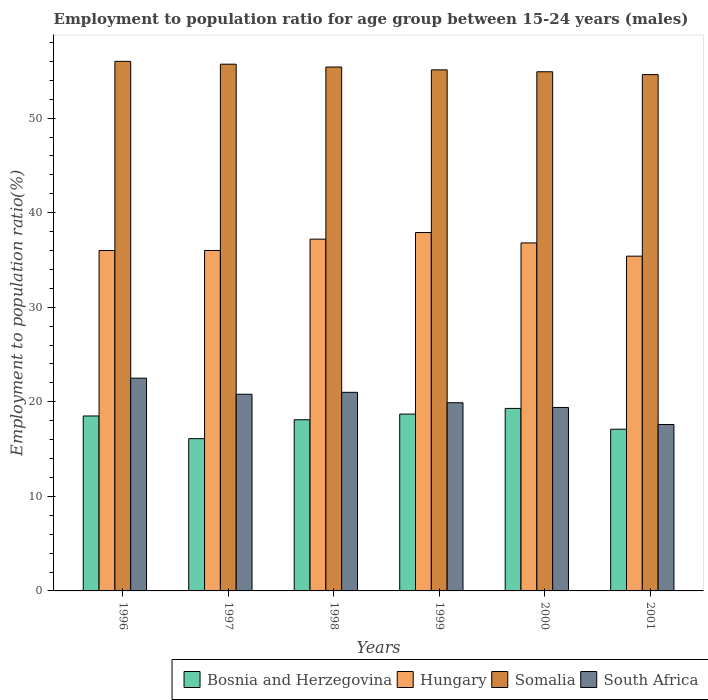How many different coloured bars are there?
Your response must be concise. 4. How many groups of bars are there?
Offer a terse response. 6. Are the number of bars per tick equal to the number of legend labels?
Make the answer very short. Yes. Are the number of bars on each tick of the X-axis equal?
Make the answer very short. Yes. What is the label of the 5th group of bars from the left?
Your response must be concise. 2000. What is the employment to population ratio in Somalia in 2000?
Give a very brief answer. 54.9. Across all years, what is the minimum employment to population ratio in Somalia?
Give a very brief answer. 54.6. In which year was the employment to population ratio in South Africa minimum?
Provide a succinct answer. 2001. What is the total employment to population ratio in South Africa in the graph?
Your answer should be very brief. 121.2. What is the difference between the employment to population ratio in South Africa in 1996 and that in 1998?
Keep it short and to the point. 1.5. What is the difference between the employment to population ratio in Hungary in 1998 and the employment to population ratio in Somalia in 1996?
Offer a terse response. -18.8. What is the average employment to population ratio in Bosnia and Herzegovina per year?
Your response must be concise. 17.97. In the year 1996, what is the difference between the employment to population ratio in Hungary and employment to population ratio in Somalia?
Keep it short and to the point. -20. What is the ratio of the employment to population ratio in Somalia in 1998 to that in 2001?
Your answer should be very brief. 1.01. What is the difference between the highest and the second highest employment to population ratio in South Africa?
Your answer should be very brief. 1.5. What is the difference between the highest and the lowest employment to population ratio in Hungary?
Make the answer very short. 2.5. Is the sum of the employment to population ratio in Somalia in 1998 and 2000 greater than the maximum employment to population ratio in South Africa across all years?
Offer a terse response. Yes. Is it the case that in every year, the sum of the employment to population ratio in Somalia and employment to population ratio in Bosnia and Herzegovina is greater than the sum of employment to population ratio in Hungary and employment to population ratio in South Africa?
Your response must be concise. No. What does the 1st bar from the left in 2001 represents?
Offer a terse response. Bosnia and Herzegovina. What does the 2nd bar from the right in 2001 represents?
Your answer should be very brief. Somalia. Is it the case that in every year, the sum of the employment to population ratio in South Africa and employment to population ratio in Bosnia and Herzegovina is greater than the employment to population ratio in Hungary?
Your answer should be compact. No. What is the difference between two consecutive major ticks on the Y-axis?
Your answer should be very brief. 10. Does the graph contain any zero values?
Offer a terse response. No. Does the graph contain grids?
Provide a short and direct response. No. How many legend labels are there?
Provide a succinct answer. 4. What is the title of the graph?
Your answer should be very brief. Employment to population ratio for age group between 15-24 years (males). Does "Slovenia" appear as one of the legend labels in the graph?
Give a very brief answer. No. What is the label or title of the Y-axis?
Keep it short and to the point. Employment to population ratio(%). What is the Employment to population ratio(%) in Bosnia and Herzegovina in 1996?
Ensure brevity in your answer.  18.5. What is the Employment to population ratio(%) of Bosnia and Herzegovina in 1997?
Your response must be concise. 16.1. What is the Employment to population ratio(%) in Hungary in 1997?
Keep it short and to the point. 36. What is the Employment to population ratio(%) in Somalia in 1997?
Give a very brief answer. 55.7. What is the Employment to population ratio(%) of South Africa in 1997?
Ensure brevity in your answer.  20.8. What is the Employment to population ratio(%) in Bosnia and Herzegovina in 1998?
Keep it short and to the point. 18.1. What is the Employment to population ratio(%) in Hungary in 1998?
Your response must be concise. 37.2. What is the Employment to population ratio(%) in Somalia in 1998?
Your answer should be very brief. 55.4. What is the Employment to population ratio(%) of Bosnia and Herzegovina in 1999?
Offer a terse response. 18.7. What is the Employment to population ratio(%) in Hungary in 1999?
Keep it short and to the point. 37.9. What is the Employment to population ratio(%) of Somalia in 1999?
Your answer should be compact. 55.1. What is the Employment to population ratio(%) in South Africa in 1999?
Give a very brief answer. 19.9. What is the Employment to population ratio(%) in Bosnia and Herzegovina in 2000?
Ensure brevity in your answer.  19.3. What is the Employment to population ratio(%) in Hungary in 2000?
Provide a succinct answer. 36.8. What is the Employment to population ratio(%) in Somalia in 2000?
Provide a short and direct response. 54.9. What is the Employment to population ratio(%) in South Africa in 2000?
Offer a very short reply. 19.4. What is the Employment to population ratio(%) in Bosnia and Herzegovina in 2001?
Provide a succinct answer. 17.1. What is the Employment to population ratio(%) in Hungary in 2001?
Keep it short and to the point. 35.4. What is the Employment to population ratio(%) of Somalia in 2001?
Make the answer very short. 54.6. What is the Employment to population ratio(%) in South Africa in 2001?
Make the answer very short. 17.6. Across all years, what is the maximum Employment to population ratio(%) of Bosnia and Herzegovina?
Give a very brief answer. 19.3. Across all years, what is the maximum Employment to population ratio(%) in Hungary?
Offer a very short reply. 37.9. Across all years, what is the minimum Employment to population ratio(%) in Bosnia and Herzegovina?
Keep it short and to the point. 16.1. Across all years, what is the minimum Employment to population ratio(%) of Hungary?
Keep it short and to the point. 35.4. Across all years, what is the minimum Employment to population ratio(%) in Somalia?
Make the answer very short. 54.6. Across all years, what is the minimum Employment to population ratio(%) in South Africa?
Provide a succinct answer. 17.6. What is the total Employment to population ratio(%) in Bosnia and Herzegovina in the graph?
Your answer should be compact. 107.8. What is the total Employment to population ratio(%) in Hungary in the graph?
Make the answer very short. 219.3. What is the total Employment to population ratio(%) in Somalia in the graph?
Offer a very short reply. 331.7. What is the total Employment to population ratio(%) of South Africa in the graph?
Offer a terse response. 121.2. What is the difference between the Employment to population ratio(%) in Bosnia and Herzegovina in 1996 and that in 1997?
Your answer should be compact. 2.4. What is the difference between the Employment to population ratio(%) in Somalia in 1996 and that in 1997?
Keep it short and to the point. 0.3. What is the difference between the Employment to population ratio(%) in South Africa in 1996 and that in 1997?
Your answer should be very brief. 1.7. What is the difference between the Employment to population ratio(%) of Hungary in 1996 and that in 1998?
Provide a short and direct response. -1.2. What is the difference between the Employment to population ratio(%) of Somalia in 1996 and that in 1998?
Provide a succinct answer. 0.6. What is the difference between the Employment to population ratio(%) of South Africa in 1996 and that in 1998?
Keep it short and to the point. 1.5. What is the difference between the Employment to population ratio(%) of Bosnia and Herzegovina in 1996 and that in 1999?
Give a very brief answer. -0.2. What is the difference between the Employment to population ratio(%) in Somalia in 1996 and that in 1999?
Provide a succinct answer. 0.9. What is the difference between the Employment to population ratio(%) of Hungary in 1996 and that in 2000?
Offer a very short reply. -0.8. What is the difference between the Employment to population ratio(%) of Bosnia and Herzegovina in 1996 and that in 2001?
Ensure brevity in your answer.  1.4. What is the difference between the Employment to population ratio(%) of Hungary in 1996 and that in 2001?
Your answer should be very brief. 0.6. What is the difference between the Employment to population ratio(%) of Somalia in 1996 and that in 2001?
Offer a very short reply. 1.4. What is the difference between the Employment to population ratio(%) of Bosnia and Herzegovina in 1997 and that in 1999?
Give a very brief answer. -2.6. What is the difference between the Employment to population ratio(%) in Somalia in 1997 and that in 1999?
Provide a short and direct response. 0.6. What is the difference between the Employment to population ratio(%) of South Africa in 1997 and that in 1999?
Your answer should be very brief. 0.9. What is the difference between the Employment to population ratio(%) in Hungary in 1997 and that in 2000?
Your answer should be very brief. -0.8. What is the difference between the Employment to population ratio(%) in Hungary in 1997 and that in 2001?
Keep it short and to the point. 0.6. What is the difference between the Employment to population ratio(%) in South Africa in 1997 and that in 2001?
Provide a short and direct response. 3.2. What is the difference between the Employment to population ratio(%) in Somalia in 1998 and that in 1999?
Offer a terse response. 0.3. What is the difference between the Employment to population ratio(%) in South Africa in 1998 and that in 1999?
Your answer should be very brief. 1.1. What is the difference between the Employment to population ratio(%) in Hungary in 1998 and that in 2000?
Provide a short and direct response. 0.4. What is the difference between the Employment to population ratio(%) in Somalia in 1998 and that in 2000?
Ensure brevity in your answer.  0.5. What is the difference between the Employment to population ratio(%) of Bosnia and Herzegovina in 1998 and that in 2001?
Ensure brevity in your answer.  1. What is the difference between the Employment to population ratio(%) in Bosnia and Herzegovina in 1999 and that in 2000?
Offer a terse response. -0.6. What is the difference between the Employment to population ratio(%) in Somalia in 1999 and that in 2000?
Provide a short and direct response. 0.2. What is the difference between the Employment to population ratio(%) of South Africa in 1999 and that in 2000?
Make the answer very short. 0.5. What is the difference between the Employment to population ratio(%) of Bosnia and Herzegovina in 2000 and that in 2001?
Your answer should be compact. 2.2. What is the difference between the Employment to population ratio(%) of Hungary in 2000 and that in 2001?
Your answer should be compact. 1.4. What is the difference between the Employment to population ratio(%) of Somalia in 2000 and that in 2001?
Give a very brief answer. 0.3. What is the difference between the Employment to population ratio(%) of South Africa in 2000 and that in 2001?
Offer a very short reply. 1.8. What is the difference between the Employment to population ratio(%) of Bosnia and Herzegovina in 1996 and the Employment to population ratio(%) of Hungary in 1997?
Keep it short and to the point. -17.5. What is the difference between the Employment to population ratio(%) of Bosnia and Herzegovina in 1996 and the Employment to population ratio(%) of Somalia in 1997?
Provide a short and direct response. -37.2. What is the difference between the Employment to population ratio(%) of Bosnia and Herzegovina in 1996 and the Employment to population ratio(%) of South Africa in 1997?
Your answer should be very brief. -2.3. What is the difference between the Employment to population ratio(%) in Hungary in 1996 and the Employment to population ratio(%) in Somalia in 1997?
Your answer should be very brief. -19.7. What is the difference between the Employment to population ratio(%) in Hungary in 1996 and the Employment to population ratio(%) in South Africa in 1997?
Provide a succinct answer. 15.2. What is the difference between the Employment to population ratio(%) of Somalia in 1996 and the Employment to population ratio(%) of South Africa in 1997?
Provide a succinct answer. 35.2. What is the difference between the Employment to population ratio(%) in Bosnia and Herzegovina in 1996 and the Employment to population ratio(%) in Hungary in 1998?
Make the answer very short. -18.7. What is the difference between the Employment to population ratio(%) of Bosnia and Herzegovina in 1996 and the Employment to population ratio(%) of Somalia in 1998?
Give a very brief answer. -36.9. What is the difference between the Employment to population ratio(%) of Bosnia and Herzegovina in 1996 and the Employment to population ratio(%) of South Africa in 1998?
Give a very brief answer. -2.5. What is the difference between the Employment to population ratio(%) in Hungary in 1996 and the Employment to population ratio(%) in Somalia in 1998?
Offer a very short reply. -19.4. What is the difference between the Employment to population ratio(%) in Somalia in 1996 and the Employment to population ratio(%) in South Africa in 1998?
Keep it short and to the point. 35. What is the difference between the Employment to population ratio(%) in Bosnia and Herzegovina in 1996 and the Employment to population ratio(%) in Hungary in 1999?
Provide a short and direct response. -19.4. What is the difference between the Employment to population ratio(%) of Bosnia and Herzegovina in 1996 and the Employment to population ratio(%) of Somalia in 1999?
Ensure brevity in your answer.  -36.6. What is the difference between the Employment to population ratio(%) in Bosnia and Herzegovina in 1996 and the Employment to population ratio(%) in South Africa in 1999?
Provide a succinct answer. -1.4. What is the difference between the Employment to population ratio(%) of Hungary in 1996 and the Employment to population ratio(%) of Somalia in 1999?
Provide a succinct answer. -19.1. What is the difference between the Employment to population ratio(%) of Somalia in 1996 and the Employment to population ratio(%) of South Africa in 1999?
Your answer should be compact. 36.1. What is the difference between the Employment to population ratio(%) of Bosnia and Herzegovina in 1996 and the Employment to population ratio(%) of Hungary in 2000?
Provide a succinct answer. -18.3. What is the difference between the Employment to population ratio(%) in Bosnia and Herzegovina in 1996 and the Employment to population ratio(%) in Somalia in 2000?
Make the answer very short. -36.4. What is the difference between the Employment to population ratio(%) of Hungary in 1996 and the Employment to population ratio(%) of Somalia in 2000?
Your response must be concise. -18.9. What is the difference between the Employment to population ratio(%) in Hungary in 1996 and the Employment to population ratio(%) in South Africa in 2000?
Make the answer very short. 16.6. What is the difference between the Employment to population ratio(%) in Somalia in 1996 and the Employment to population ratio(%) in South Africa in 2000?
Your answer should be compact. 36.6. What is the difference between the Employment to population ratio(%) of Bosnia and Herzegovina in 1996 and the Employment to population ratio(%) of Hungary in 2001?
Provide a succinct answer. -16.9. What is the difference between the Employment to population ratio(%) in Bosnia and Herzegovina in 1996 and the Employment to population ratio(%) in Somalia in 2001?
Offer a terse response. -36.1. What is the difference between the Employment to population ratio(%) of Hungary in 1996 and the Employment to population ratio(%) of Somalia in 2001?
Make the answer very short. -18.6. What is the difference between the Employment to population ratio(%) of Hungary in 1996 and the Employment to population ratio(%) of South Africa in 2001?
Your answer should be compact. 18.4. What is the difference between the Employment to population ratio(%) in Somalia in 1996 and the Employment to population ratio(%) in South Africa in 2001?
Make the answer very short. 38.4. What is the difference between the Employment to population ratio(%) in Bosnia and Herzegovina in 1997 and the Employment to population ratio(%) in Hungary in 1998?
Make the answer very short. -21.1. What is the difference between the Employment to population ratio(%) in Bosnia and Herzegovina in 1997 and the Employment to population ratio(%) in Somalia in 1998?
Your answer should be very brief. -39.3. What is the difference between the Employment to population ratio(%) of Hungary in 1997 and the Employment to population ratio(%) of Somalia in 1998?
Your answer should be compact. -19.4. What is the difference between the Employment to population ratio(%) of Hungary in 1997 and the Employment to population ratio(%) of South Africa in 1998?
Give a very brief answer. 15. What is the difference between the Employment to population ratio(%) of Somalia in 1997 and the Employment to population ratio(%) of South Africa in 1998?
Keep it short and to the point. 34.7. What is the difference between the Employment to population ratio(%) in Bosnia and Herzegovina in 1997 and the Employment to population ratio(%) in Hungary in 1999?
Your answer should be compact. -21.8. What is the difference between the Employment to population ratio(%) of Bosnia and Herzegovina in 1997 and the Employment to population ratio(%) of Somalia in 1999?
Make the answer very short. -39. What is the difference between the Employment to population ratio(%) of Hungary in 1997 and the Employment to population ratio(%) of Somalia in 1999?
Give a very brief answer. -19.1. What is the difference between the Employment to population ratio(%) in Hungary in 1997 and the Employment to population ratio(%) in South Africa in 1999?
Give a very brief answer. 16.1. What is the difference between the Employment to population ratio(%) of Somalia in 1997 and the Employment to population ratio(%) of South Africa in 1999?
Offer a terse response. 35.8. What is the difference between the Employment to population ratio(%) of Bosnia and Herzegovina in 1997 and the Employment to population ratio(%) of Hungary in 2000?
Provide a short and direct response. -20.7. What is the difference between the Employment to population ratio(%) of Bosnia and Herzegovina in 1997 and the Employment to population ratio(%) of Somalia in 2000?
Ensure brevity in your answer.  -38.8. What is the difference between the Employment to population ratio(%) of Bosnia and Herzegovina in 1997 and the Employment to population ratio(%) of South Africa in 2000?
Your response must be concise. -3.3. What is the difference between the Employment to population ratio(%) in Hungary in 1997 and the Employment to population ratio(%) in Somalia in 2000?
Offer a terse response. -18.9. What is the difference between the Employment to population ratio(%) of Hungary in 1997 and the Employment to population ratio(%) of South Africa in 2000?
Keep it short and to the point. 16.6. What is the difference between the Employment to population ratio(%) of Somalia in 1997 and the Employment to population ratio(%) of South Africa in 2000?
Ensure brevity in your answer.  36.3. What is the difference between the Employment to population ratio(%) of Bosnia and Herzegovina in 1997 and the Employment to population ratio(%) of Hungary in 2001?
Offer a terse response. -19.3. What is the difference between the Employment to population ratio(%) in Bosnia and Herzegovina in 1997 and the Employment to population ratio(%) in Somalia in 2001?
Offer a very short reply. -38.5. What is the difference between the Employment to population ratio(%) in Bosnia and Herzegovina in 1997 and the Employment to population ratio(%) in South Africa in 2001?
Keep it short and to the point. -1.5. What is the difference between the Employment to population ratio(%) of Hungary in 1997 and the Employment to population ratio(%) of Somalia in 2001?
Your answer should be very brief. -18.6. What is the difference between the Employment to population ratio(%) in Somalia in 1997 and the Employment to population ratio(%) in South Africa in 2001?
Give a very brief answer. 38.1. What is the difference between the Employment to population ratio(%) of Bosnia and Herzegovina in 1998 and the Employment to population ratio(%) of Hungary in 1999?
Your answer should be compact. -19.8. What is the difference between the Employment to population ratio(%) in Bosnia and Herzegovina in 1998 and the Employment to population ratio(%) in Somalia in 1999?
Keep it short and to the point. -37. What is the difference between the Employment to population ratio(%) in Bosnia and Herzegovina in 1998 and the Employment to population ratio(%) in South Africa in 1999?
Your answer should be very brief. -1.8. What is the difference between the Employment to population ratio(%) of Hungary in 1998 and the Employment to population ratio(%) of Somalia in 1999?
Your answer should be compact. -17.9. What is the difference between the Employment to population ratio(%) of Somalia in 1998 and the Employment to population ratio(%) of South Africa in 1999?
Ensure brevity in your answer.  35.5. What is the difference between the Employment to population ratio(%) in Bosnia and Herzegovina in 1998 and the Employment to population ratio(%) in Hungary in 2000?
Offer a terse response. -18.7. What is the difference between the Employment to population ratio(%) of Bosnia and Herzegovina in 1998 and the Employment to population ratio(%) of Somalia in 2000?
Your answer should be compact. -36.8. What is the difference between the Employment to population ratio(%) in Hungary in 1998 and the Employment to population ratio(%) in Somalia in 2000?
Make the answer very short. -17.7. What is the difference between the Employment to population ratio(%) in Bosnia and Herzegovina in 1998 and the Employment to population ratio(%) in Hungary in 2001?
Give a very brief answer. -17.3. What is the difference between the Employment to population ratio(%) of Bosnia and Herzegovina in 1998 and the Employment to population ratio(%) of Somalia in 2001?
Give a very brief answer. -36.5. What is the difference between the Employment to population ratio(%) in Bosnia and Herzegovina in 1998 and the Employment to population ratio(%) in South Africa in 2001?
Your answer should be compact. 0.5. What is the difference between the Employment to population ratio(%) in Hungary in 1998 and the Employment to population ratio(%) in Somalia in 2001?
Offer a terse response. -17.4. What is the difference between the Employment to population ratio(%) in Hungary in 1998 and the Employment to population ratio(%) in South Africa in 2001?
Offer a terse response. 19.6. What is the difference between the Employment to population ratio(%) in Somalia in 1998 and the Employment to population ratio(%) in South Africa in 2001?
Your response must be concise. 37.8. What is the difference between the Employment to population ratio(%) of Bosnia and Herzegovina in 1999 and the Employment to population ratio(%) of Hungary in 2000?
Offer a terse response. -18.1. What is the difference between the Employment to population ratio(%) in Bosnia and Herzegovina in 1999 and the Employment to population ratio(%) in Somalia in 2000?
Make the answer very short. -36.2. What is the difference between the Employment to population ratio(%) in Hungary in 1999 and the Employment to population ratio(%) in Somalia in 2000?
Keep it short and to the point. -17. What is the difference between the Employment to population ratio(%) of Somalia in 1999 and the Employment to population ratio(%) of South Africa in 2000?
Offer a terse response. 35.7. What is the difference between the Employment to population ratio(%) of Bosnia and Herzegovina in 1999 and the Employment to population ratio(%) of Hungary in 2001?
Provide a succinct answer. -16.7. What is the difference between the Employment to population ratio(%) in Bosnia and Herzegovina in 1999 and the Employment to population ratio(%) in Somalia in 2001?
Provide a short and direct response. -35.9. What is the difference between the Employment to population ratio(%) in Hungary in 1999 and the Employment to population ratio(%) in Somalia in 2001?
Your answer should be compact. -16.7. What is the difference between the Employment to population ratio(%) of Hungary in 1999 and the Employment to population ratio(%) of South Africa in 2001?
Your answer should be compact. 20.3. What is the difference between the Employment to population ratio(%) of Somalia in 1999 and the Employment to population ratio(%) of South Africa in 2001?
Ensure brevity in your answer.  37.5. What is the difference between the Employment to population ratio(%) in Bosnia and Herzegovina in 2000 and the Employment to population ratio(%) in Hungary in 2001?
Your response must be concise. -16.1. What is the difference between the Employment to population ratio(%) in Bosnia and Herzegovina in 2000 and the Employment to population ratio(%) in Somalia in 2001?
Ensure brevity in your answer.  -35.3. What is the difference between the Employment to population ratio(%) of Bosnia and Herzegovina in 2000 and the Employment to population ratio(%) of South Africa in 2001?
Your answer should be compact. 1.7. What is the difference between the Employment to population ratio(%) in Hungary in 2000 and the Employment to population ratio(%) in Somalia in 2001?
Ensure brevity in your answer.  -17.8. What is the difference between the Employment to population ratio(%) in Somalia in 2000 and the Employment to population ratio(%) in South Africa in 2001?
Keep it short and to the point. 37.3. What is the average Employment to population ratio(%) of Bosnia and Herzegovina per year?
Your answer should be compact. 17.97. What is the average Employment to population ratio(%) of Hungary per year?
Keep it short and to the point. 36.55. What is the average Employment to population ratio(%) in Somalia per year?
Provide a succinct answer. 55.28. What is the average Employment to population ratio(%) in South Africa per year?
Your answer should be compact. 20.2. In the year 1996, what is the difference between the Employment to population ratio(%) in Bosnia and Herzegovina and Employment to population ratio(%) in Hungary?
Give a very brief answer. -17.5. In the year 1996, what is the difference between the Employment to population ratio(%) of Bosnia and Herzegovina and Employment to population ratio(%) of Somalia?
Your answer should be compact. -37.5. In the year 1996, what is the difference between the Employment to population ratio(%) in Hungary and Employment to population ratio(%) in Somalia?
Your response must be concise. -20. In the year 1996, what is the difference between the Employment to population ratio(%) in Somalia and Employment to population ratio(%) in South Africa?
Provide a short and direct response. 33.5. In the year 1997, what is the difference between the Employment to population ratio(%) of Bosnia and Herzegovina and Employment to population ratio(%) of Hungary?
Give a very brief answer. -19.9. In the year 1997, what is the difference between the Employment to population ratio(%) in Bosnia and Herzegovina and Employment to population ratio(%) in Somalia?
Keep it short and to the point. -39.6. In the year 1997, what is the difference between the Employment to population ratio(%) in Bosnia and Herzegovina and Employment to population ratio(%) in South Africa?
Provide a short and direct response. -4.7. In the year 1997, what is the difference between the Employment to population ratio(%) of Hungary and Employment to population ratio(%) of Somalia?
Give a very brief answer. -19.7. In the year 1997, what is the difference between the Employment to population ratio(%) of Hungary and Employment to population ratio(%) of South Africa?
Offer a terse response. 15.2. In the year 1997, what is the difference between the Employment to population ratio(%) in Somalia and Employment to population ratio(%) in South Africa?
Provide a short and direct response. 34.9. In the year 1998, what is the difference between the Employment to population ratio(%) in Bosnia and Herzegovina and Employment to population ratio(%) in Hungary?
Your response must be concise. -19.1. In the year 1998, what is the difference between the Employment to population ratio(%) in Bosnia and Herzegovina and Employment to population ratio(%) in Somalia?
Keep it short and to the point. -37.3. In the year 1998, what is the difference between the Employment to population ratio(%) in Bosnia and Herzegovina and Employment to population ratio(%) in South Africa?
Offer a very short reply. -2.9. In the year 1998, what is the difference between the Employment to population ratio(%) in Hungary and Employment to population ratio(%) in Somalia?
Your answer should be very brief. -18.2. In the year 1998, what is the difference between the Employment to population ratio(%) in Hungary and Employment to population ratio(%) in South Africa?
Your answer should be compact. 16.2. In the year 1998, what is the difference between the Employment to population ratio(%) in Somalia and Employment to population ratio(%) in South Africa?
Provide a succinct answer. 34.4. In the year 1999, what is the difference between the Employment to population ratio(%) of Bosnia and Herzegovina and Employment to population ratio(%) of Hungary?
Your response must be concise. -19.2. In the year 1999, what is the difference between the Employment to population ratio(%) of Bosnia and Herzegovina and Employment to population ratio(%) of Somalia?
Provide a short and direct response. -36.4. In the year 1999, what is the difference between the Employment to population ratio(%) in Hungary and Employment to population ratio(%) in Somalia?
Ensure brevity in your answer.  -17.2. In the year 1999, what is the difference between the Employment to population ratio(%) of Somalia and Employment to population ratio(%) of South Africa?
Give a very brief answer. 35.2. In the year 2000, what is the difference between the Employment to population ratio(%) of Bosnia and Herzegovina and Employment to population ratio(%) of Hungary?
Provide a short and direct response. -17.5. In the year 2000, what is the difference between the Employment to population ratio(%) in Bosnia and Herzegovina and Employment to population ratio(%) in Somalia?
Make the answer very short. -35.6. In the year 2000, what is the difference between the Employment to population ratio(%) in Hungary and Employment to population ratio(%) in Somalia?
Ensure brevity in your answer.  -18.1. In the year 2000, what is the difference between the Employment to population ratio(%) in Somalia and Employment to population ratio(%) in South Africa?
Your response must be concise. 35.5. In the year 2001, what is the difference between the Employment to population ratio(%) in Bosnia and Herzegovina and Employment to population ratio(%) in Hungary?
Your answer should be compact. -18.3. In the year 2001, what is the difference between the Employment to population ratio(%) of Bosnia and Herzegovina and Employment to population ratio(%) of Somalia?
Your answer should be compact. -37.5. In the year 2001, what is the difference between the Employment to population ratio(%) in Bosnia and Herzegovina and Employment to population ratio(%) in South Africa?
Ensure brevity in your answer.  -0.5. In the year 2001, what is the difference between the Employment to population ratio(%) of Hungary and Employment to population ratio(%) of Somalia?
Provide a short and direct response. -19.2. In the year 2001, what is the difference between the Employment to population ratio(%) of Hungary and Employment to population ratio(%) of South Africa?
Your response must be concise. 17.8. In the year 2001, what is the difference between the Employment to population ratio(%) in Somalia and Employment to population ratio(%) in South Africa?
Offer a very short reply. 37. What is the ratio of the Employment to population ratio(%) in Bosnia and Herzegovina in 1996 to that in 1997?
Provide a short and direct response. 1.15. What is the ratio of the Employment to population ratio(%) of Hungary in 1996 to that in 1997?
Make the answer very short. 1. What is the ratio of the Employment to population ratio(%) in Somalia in 1996 to that in 1997?
Your answer should be compact. 1.01. What is the ratio of the Employment to population ratio(%) in South Africa in 1996 to that in 1997?
Make the answer very short. 1.08. What is the ratio of the Employment to population ratio(%) of Bosnia and Herzegovina in 1996 to that in 1998?
Offer a terse response. 1.02. What is the ratio of the Employment to population ratio(%) in Somalia in 1996 to that in 1998?
Give a very brief answer. 1.01. What is the ratio of the Employment to population ratio(%) in South Africa in 1996 to that in 1998?
Offer a very short reply. 1.07. What is the ratio of the Employment to population ratio(%) in Bosnia and Herzegovina in 1996 to that in 1999?
Keep it short and to the point. 0.99. What is the ratio of the Employment to population ratio(%) in Hungary in 1996 to that in 1999?
Make the answer very short. 0.95. What is the ratio of the Employment to population ratio(%) in Somalia in 1996 to that in 1999?
Your response must be concise. 1.02. What is the ratio of the Employment to population ratio(%) of South Africa in 1996 to that in 1999?
Offer a terse response. 1.13. What is the ratio of the Employment to population ratio(%) of Bosnia and Herzegovina in 1996 to that in 2000?
Your response must be concise. 0.96. What is the ratio of the Employment to population ratio(%) in Hungary in 1996 to that in 2000?
Keep it short and to the point. 0.98. What is the ratio of the Employment to population ratio(%) in Somalia in 1996 to that in 2000?
Your response must be concise. 1.02. What is the ratio of the Employment to population ratio(%) of South Africa in 1996 to that in 2000?
Keep it short and to the point. 1.16. What is the ratio of the Employment to population ratio(%) of Bosnia and Herzegovina in 1996 to that in 2001?
Your answer should be compact. 1.08. What is the ratio of the Employment to population ratio(%) of Hungary in 1996 to that in 2001?
Your answer should be very brief. 1.02. What is the ratio of the Employment to population ratio(%) of Somalia in 1996 to that in 2001?
Ensure brevity in your answer.  1.03. What is the ratio of the Employment to population ratio(%) of South Africa in 1996 to that in 2001?
Give a very brief answer. 1.28. What is the ratio of the Employment to population ratio(%) of Bosnia and Herzegovina in 1997 to that in 1998?
Keep it short and to the point. 0.89. What is the ratio of the Employment to population ratio(%) in Somalia in 1997 to that in 1998?
Your response must be concise. 1.01. What is the ratio of the Employment to population ratio(%) of South Africa in 1997 to that in 1998?
Your answer should be very brief. 0.99. What is the ratio of the Employment to population ratio(%) in Bosnia and Herzegovina in 1997 to that in 1999?
Provide a succinct answer. 0.86. What is the ratio of the Employment to population ratio(%) in Hungary in 1997 to that in 1999?
Give a very brief answer. 0.95. What is the ratio of the Employment to population ratio(%) in Somalia in 1997 to that in 1999?
Your response must be concise. 1.01. What is the ratio of the Employment to population ratio(%) in South Africa in 1997 to that in 1999?
Give a very brief answer. 1.05. What is the ratio of the Employment to population ratio(%) in Bosnia and Herzegovina in 1997 to that in 2000?
Your answer should be compact. 0.83. What is the ratio of the Employment to population ratio(%) of Hungary in 1997 to that in 2000?
Your response must be concise. 0.98. What is the ratio of the Employment to population ratio(%) of Somalia in 1997 to that in 2000?
Give a very brief answer. 1.01. What is the ratio of the Employment to population ratio(%) in South Africa in 1997 to that in 2000?
Ensure brevity in your answer.  1.07. What is the ratio of the Employment to population ratio(%) in Bosnia and Herzegovina in 1997 to that in 2001?
Give a very brief answer. 0.94. What is the ratio of the Employment to population ratio(%) of Hungary in 1997 to that in 2001?
Provide a short and direct response. 1.02. What is the ratio of the Employment to population ratio(%) of Somalia in 1997 to that in 2001?
Your response must be concise. 1.02. What is the ratio of the Employment to population ratio(%) of South Africa in 1997 to that in 2001?
Give a very brief answer. 1.18. What is the ratio of the Employment to population ratio(%) in Bosnia and Herzegovina in 1998 to that in 1999?
Offer a very short reply. 0.97. What is the ratio of the Employment to population ratio(%) of Hungary in 1998 to that in 1999?
Offer a terse response. 0.98. What is the ratio of the Employment to population ratio(%) in Somalia in 1998 to that in 1999?
Your answer should be very brief. 1.01. What is the ratio of the Employment to population ratio(%) of South Africa in 1998 to that in 1999?
Make the answer very short. 1.06. What is the ratio of the Employment to population ratio(%) of Bosnia and Herzegovina in 1998 to that in 2000?
Provide a succinct answer. 0.94. What is the ratio of the Employment to population ratio(%) of Hungary in 1998 to that in 2000?
Provide a succinct answer. 1.01. What is the ratio of the Employment to population ratio(%) of Somalia in 1998 to that in 2000?
Offer a very short reply. 1.01. What is the ratio of the Employment to population ratio(%) of South Africa in 1998 to that in 2000?
Give a very brief answer. 1.08. What is the ratio of the Employment to population ratio(%) of Bosnia and Herzegovina in 1998 to that in 2001?
Provide a succinct answer. 1.06. What is the ratio of the Employment to population ratio(%) of Hungary in 1998 to that in 2001?
Keep it short and to the point. 1.05. What is the ratio of the Employment to population ratio(%) of Somalia in 1998 to that in 2001?
Your answer should be compact. 1.01. What is the ratio of the Employment to population ratio(%) in South Africa in 1998 to that in 2001?
Ensure brevity in your answer.  1.19. What is the ratio of the Employment to population ratio(%) of Bosnia and Herzegovina in 1999 to that in 2000?
Your response must be concise. 0.97. What is the ratio of the Employment to population ratio(%) in Hungary in 1999 to that in 2000?
Offer a terse response. 1.03. What is the ratio of the Employment to population ratio(%) in South Africa in 1999 to that in 2000?
Keep it short and to the point. 1.03. What is the ratio of the Employment to population ratio(%) of Bosnia and Herzegovina in 1999 to that in 2001?
Ensure brevity in your answer.  1.09. What is the ratio of the Employment to population ratio(%) of Hungary in 1999 to that in 2001?
Ensure brevity in your answer.  1.07. What is the ratio of the Employment to population ratio(%) of Somalia in 1999 to that in 2001?
Provide a short and direct response. 1.01. What is the ratio of the Employment to population ratio(%) of South Africa in 1999 to that in 2001?
Provide a succinct answer. 1.13. What is the ratio of the Employment to population ratio(%) of Bosnia and Herzegovina in 2000 to that in 2001?
Provide a succinct answer. 1.13. What is the ratio of the Employment to population ratio(%) in Hungary in 2000 to that in 2001?
Make the answer very short. 1.04. What is the ratio of the Employment to population ratio(%) of Somalia in 2000 to that in 2001?
Your answer should be very brief. 1.01. What is the ratio of the Employment to population ratio(%) of South Africa in 2000 to that in 2001?
Your answer should be very brief. 1.1. What is the difference between the highest and the second highest Employment to population ratio(%) of Bosnia and Herzegovina?
Provide a short and direct response. 0.6. What is the difference between the highest and the second highest Employment to population ratio(%) in Hungary?
Ensure brevity in your answer.  0.7. What is the difference between the highest and the second highest Employment to population ratio(%) of South Africa?
Offer a very short reply. 1.5. What is the difference between the highest and the lowest Employment to population ratio(%) of Hungary?
Ensure brevity in your answer.  2.5. What is the difference between the highest and the lowest Employment to population ratio(%) in Somalia?
Offer a terse response. 1.4. 